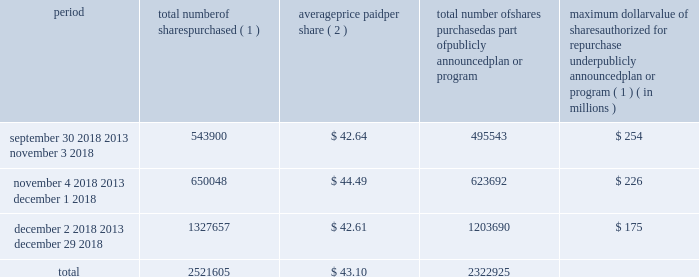Issuer purchases of equity securities in january 2017 , our board of directors authorized the repurchase of shares of our common stock with a value of up to $ 525 million in the aggregate .
As of december 29 , 2018 , $ 175 million remained available under this authorization .
In february 2019 , our board of directors authorized the additional repurchase of shares of our common stock with a value of up to $ 500.0 million in the aggregate .
The actual timing and amount of repurchases are subject to business and market conditions , corporate and regulatory requirements , stock price , acquisition opportunities and other factors .
The table presents repurchases made under our current authorization and shares surrendered by employees to satisfy income tax withholding obligations during the three months ended december 29 , 2018 : period total number of shares purchased ( 1 ) average price paid per share ( 2 ) total number of shares purchased as part of publicly announced plan or program maximum dollar value of shares authorized for repurchase under publicly announced plan or program ( 1 ) ( in millions ) september 30 , 2018 2013 november 3 , 2018 543900 $ 42.64 495543 $ 254 november 4 , 2018 2013 december 1 , 2018 650048 $ 44.49 623692 $ 226 december 2 , 2018 2013 december 29 , 2018 1327657 $ 42.61 1203690 $ 175 .
( 1 ) shares purchased that were not part of our publicly announced repurchase programs represent employee surrender of shares of restricted stock to satisfy employee income tax withholding obligations due upon vesting , and do not reduce the dollar value that may yet be purchased under our publicly announced repurchase programs .
( 2 ) the weighted average price paid per share of common stock does not include the cost of commissions. .
What was the average number of total shares purchased for the three monthly periods ending december 29 , 2018? 
Computations: (2521605 / 3)
Answer: 840535.0. 